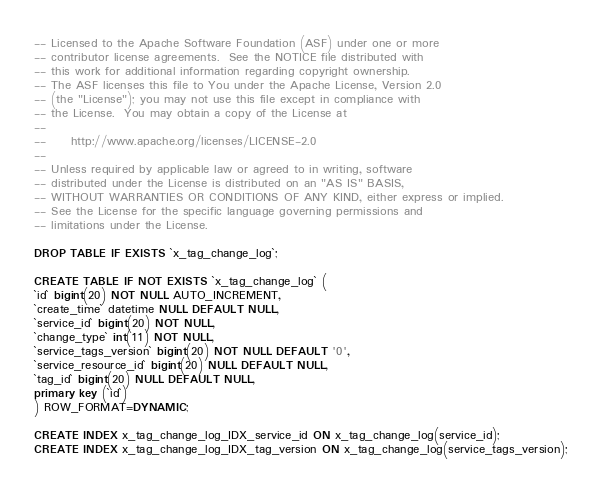<code> <loc_0><loc_0><loc_500><loc_500><_SQL_>-- Licensed to the Apache Software Foundation (ASF) under one or more
-- contributor license agreements.  See the NOTICE file distributed with
-- this work for additional information regarding copyright ownership.
-- The ASF licenses this file to You under the Apache License, Version 2.0
-- (the "License"); you may not use this file except in compliance with
-- the License.  You may obtain a copy of the License at
--
--     http://www.apache.org/licenses/LICENSE-2.0
--
-- Unless required by applicable law or agreed to in writing, software
-- distributed under the License is distributed on an "AS IS" BASIS,
-- WITHOUT WARRANTIES OR CONDITIONS OF ANY KIND, either express or implied.
-- See the License for the specific language governing permissions and
-- limitations under the License.

DROP TABLE IF EXISTS `x_tag_change_log`;

CREATE TABLE IF NOT EXISTS `x_tag_change_log` (
`id` bigint(20) NOT NULL AUTO_INCREMENT,
`create_time` datetime NULL DEFAULT NULL,
`service_id` bigint(20) NOT NULL,
`change_type` int(11) NOT NULL,
`service_tags_version` bigint(20) NOT NULL DEFAULT '0',
`service_resource_id` bigint(20) NULL DEFAULT NULL,
`tag_id` bigint(20) NULL DEFAULT NULL,
primary key (`id`)
) ROW_FORMAT=DYNAMIC;

CREATE INDEX x_tag_change_log_IDX_service_id ON x_tag_change_log(service_id);
CREATE INDEX x_tag_change_log_IDX_tag_version ON x_tag_change_log(service_tags_version);

</code> 